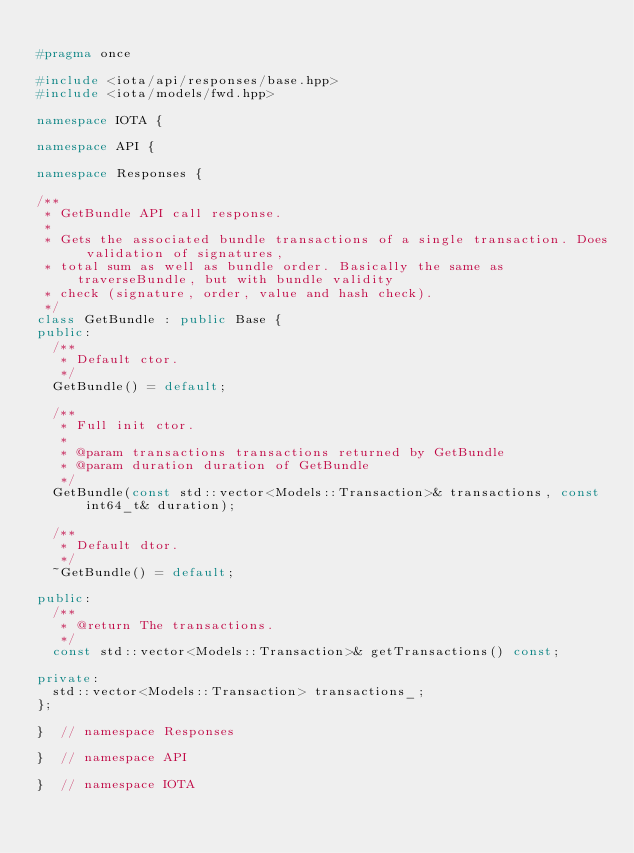Convert code to text. <code><loc_0><loc_0><loc_500><loc_500><_C++_>
#pragma once

#include <iota/api/responses/base.hpp>
#include <iota/models/fwd.hpp>

namespace IOTA {

namespace API {

namespace Responses {

/**
 * GetBundle API call response.
 *
 * Gets the associated bundle transactions of a single transaction. Does validation of signatures,
 * total sum as well as bundle order. Basically the same as traverseBundle, but with bundle validity
 * check (signature, order, value and hash check).
 */
class GetBundle : public Base {
public:
  /**
   * Default ctor.
   */
  GetBundle() = default;

  /**
   * Full init ctor.
   *
   * @param transactions transactions returned by GetBundle
   * @param duration duration of GetBundle
   */
  GetBundle(const std::vector<Models::Transaction>& transactions, const int64_t& duration);

  /**
   * Default dtor.
   */
  ~GetBundle() = default;

public:
  /**
   * @return The transactions.
   */
  const std::vector<Models::Transaction>& getTransactions() const;

private:
  std::vector<Models::Transaction> transactions_;
};

}  // namespace Responses

}  // namespace API

}  // namespace IOTA
</code> 